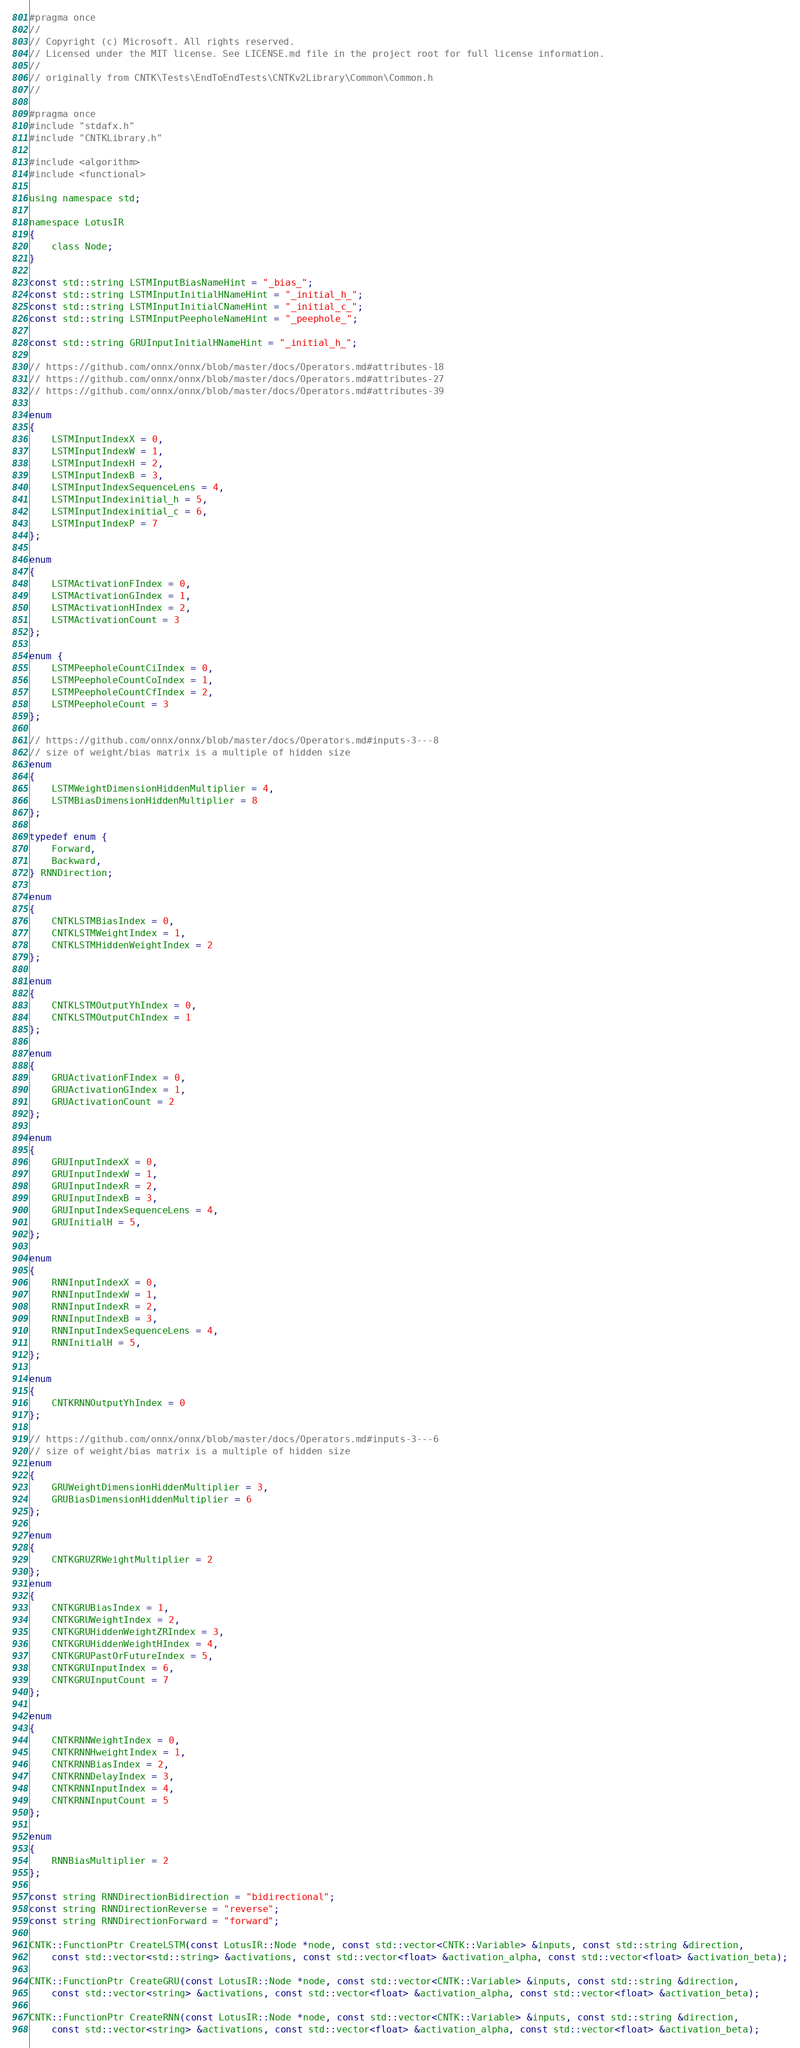<code> <loc_0><loc_0><loc_500><loc_500><_C_>#pragma once
//
// Copyright (c) Microsoft. All rights reserved.
// Licensed under the MIT license. See LICENSE.md file in the project root for full license information.
//
// originally from CNTK\Tests\EndToEndTests\CNTKv2Library\Common\Common.h
// 

#pragma once
#include "stdafx.h"
#include "CNTKLibrary.h"

#include <algorithm>
#include <functional>

using namespace std;

namespace LotusIR
{
    class Node;
}

const std::string LSTMInputBiasNameHint = "_bias_";
const std::string LSTMInputInitialHNameHint = "_initial_h_";
const std::string LSTMInputInitialCNameHint = "_initial_c_";
const std::string LSTMInputPeepholeNameHint = "_peephole_";

const std::string GRUInputInitialHNameHint = "_initial_h_";

// https://github.com/onnx/onnx/blob/master/docs/Operators.md#attributes-18
// https://github.com/onnx/onnx/blob/master/docs/Operators.md#attributes-27
// https://github.com/onnx/onnx/blob/master/docs/Operators.md#attributes-39

enum
{
    LSTMInputIndexX = 0,
    LSTMInputIndexW = 1,
    LSTMInputIndexH = 2,
    LSTMInputIndexB = 3,
    LSTMInputIndexSequenceLens = 4,
    LSTMInputIndexinitial_h = 5,
    LSTMInputIndexinitial_c = 6,
    LSTMInputIndexP = 7
};

enum
{
    LSTMActivationFIndex = 0,
    LSTMActivationGIndex = 1,
    LSTMActivationHIndex = 2,
    LSTMActivationCount = 3
};

enum {
    LSTMPeepholeCountCiIndex = 0,
    LSTMPeepholeCountCoIndex = 1,
    LSTMPeepholeCountCfIndex = 2,
    LSTMPeepholeCount = 3
};

// https://github.com/onnx/onnx/blob/master/docs/Operators.md#inputs-3---8
// size of weight/bias matrix is a multiple of hidden size
enum
{
    LSTMWeightDimensionHiddenMultiplier = 4,
    LSTMBiasDimensionHiddenMultiplier = 8
};

typedef enum {
    Forward,
    Backward,
} RNNDirection;

enum
{
    CNTKLSTMBiasIndex = 0,
    CNTKLSTMWeightIndex = 1,
    CNTKLSTMHiddenWeightIndex = 2
};

enum
{
    CNTKLSTMOutputYhIndex = 0,
    CNTKLSTMOutputChIndex = 1
};

enum
{
    GRUActivationFIndex = 0,
    GRUActivationGIndex = 1,
    GRUActivationCount = 2
};

enum
{
    GRUInputIndexX = 0,
    GRUInputIndexW = 1,
    GRUInputIndexR = 2,
    GRUInputIndexB = 3,
    GRUInputIndexSequenceLens = 4,
    GRUInitialH = 5,
};

enum
{
    RNNInputIndexX = 0,
    RNNInputIndexW = 1,
    RNNInputIndexR = 2,
    RNNInputIndexB = 3,
    RNNInputIndexSequenceLens = 4,
    RNNInitialH = 5,
};

enum
{
    CNTKRNNOutputYhIndex = 0
};

// https://github.com/onnx/onnx/blob/master/docs/Operators.md#inputs-3---6
// size of weight/bias matrix is a multiple of hidden size
enum
{
    GRUWeightDimensionHiddenMultiplier = 3,
    GRUBiasDimensionHiddenMultiplier = 6
};

enum
{
    CNTKGRUZRWeightMultiplier = 2
};
enum
{
    CNTKGRUBiasIndex = 1,
    CNTKGRUWeightIndex = 2,
    CNTKGRUHiddenWeightZRIndex = 3,
    CNTKGRUHiddenWeightHIndex = 4,
    CNTKGRUPastOrFutureIndex = 5,
    CNTKGRUInputIndex = 6,
    CNTKGRUInputCount = 7
};

enum
{
    CNTKRNNWeightIndex = 0,
    CNTKRNNHweightIndex = 1,
    CNTKRNNBiasIndex = 2,
    CNTKRNNDelayIndex = 3,
    CNTKRNNInputIndex = 4,
    CNTKRNNInputCount = 5
};

enum
{
    RNNBiasMultiplier = 2
};

const string RNNDirectionBidirection = "bidirectional";
const string RNNDirectionReverse = "reverse";
const string RNNDirectionForward = "forward";

CNTK::FunctionPtr CreateLSTM(const LotusIR::Node *node, const std::vector<CNTK::Variable> &inputs, const std::string &direction,
    const std::vector<std::string> &activations, const std::vector<float> &activation_alpha, const std::vector<float> &activation_beta);

CNTK::FunctionPtr CreateGRU(const LotusIR::Node *node, const std::vector<CNTK::Variable> &inputs, const std::string &direction,
    const std::vector<string> &activations, const std::vector<float> &activation_alpha, const std::vector<float> &activation_beta);

CNTK::FunctionPtr CreateRNN(const LotusIR::Node *node, const std::vector<CNTK::Variable> &inputs, const std::string &direction,
    const std::vector<string> &activations, const std::vector<float> &activation_alpha, const std::vector<float> &activation_beta);
</code> 